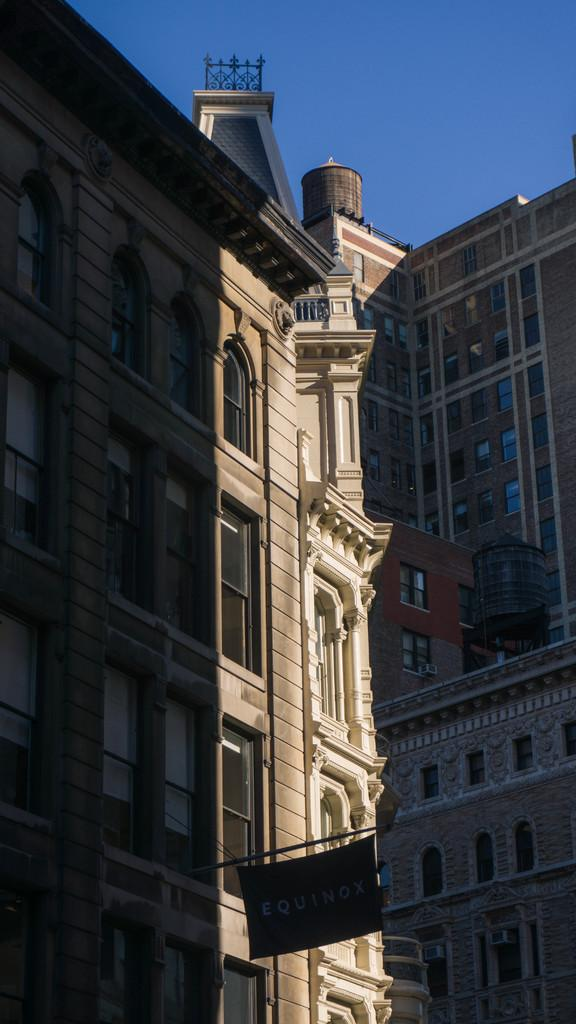What type of structures are present in the image? There are buildings in the image. What are some features of the buildings? The buildings have walls, pillars, and windows. What else can be seen in the image besides the buildings? There is a pole with a flag in the image. What is visible at the top of the image? The sky is visible at the top of the image. Can you tell me how many horses are running around the buildings in the image? There are no horses present in the image; it only features buildings, a pole with a flag, and the sky. Is there a band playing music in the image? There is no band present in the image. 